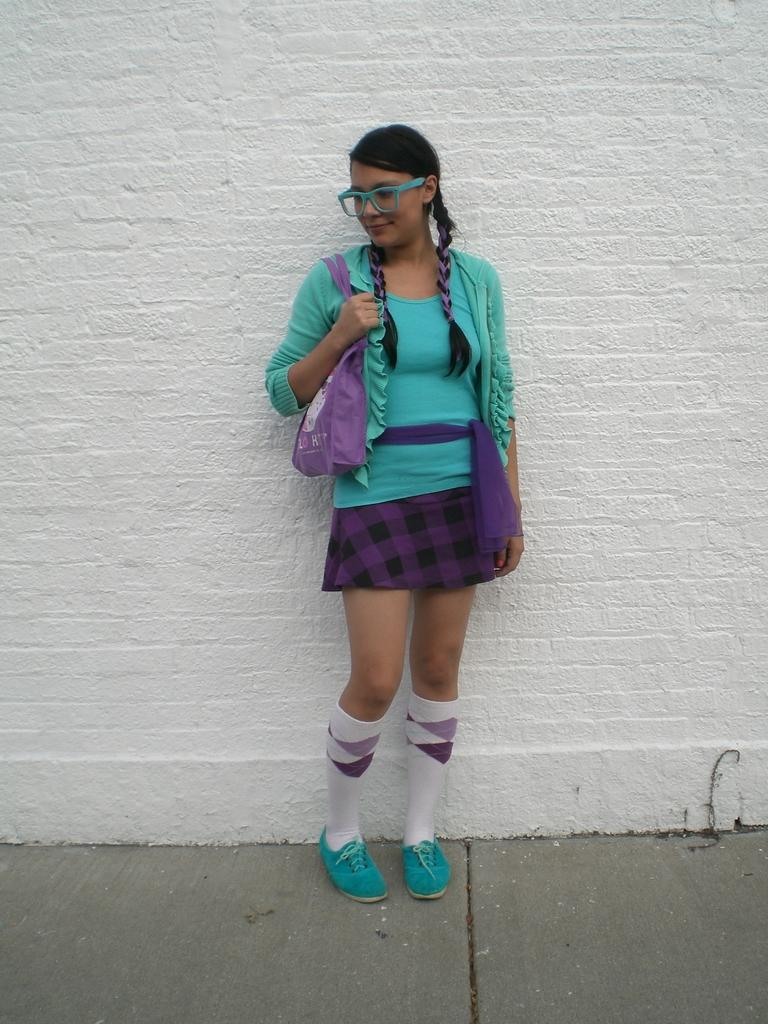Who is present in the image? There is a lady in the image. What is the lady wearing on her face? The lady is wearing spectacles. What is the lady holding in the image? The lady is carrying a bag. Where is the lady standing in the image? The lady is standing on a pavement. What can be seen in the background of the image? There is a white wall in the background of the image. What rule does the lady's uncle enforce in the image? There is no mention of an uncle in the image, so it is not possible to determine any rules he might enforce. 